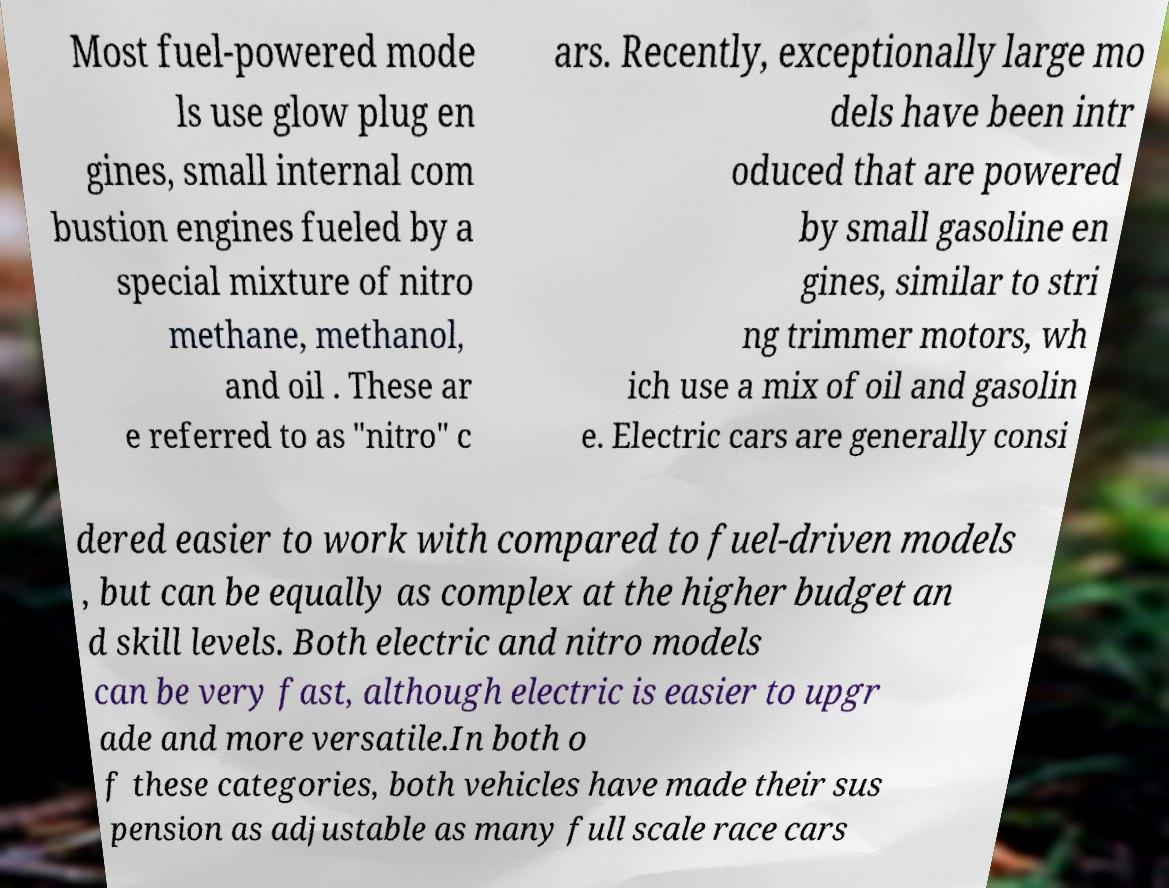For documentation purposes, I need the text within this image transcribed. Could you provide that? Most fuel-powered mode ls use glow plug en gines, small internal com bustion engines fueled by a special mixture of nitro methane, methanol, and oil . These ar e referred to as "nitro" c ars. Recently, exceptionally large mo dels have been intr oduced that are powered by small gasoline en gines, similar to stri ng trimmer motors, wh ich use a mix of oil and gasolin e. Electric cars are generally consi dered easier to work with compared to fuel-driven models , but can be equally as complex at the higher budget an d skill levels. Both electric and nitro models can be very fast, although electric is easier to upgr ade and more versatile.In both o f these categories, both vehicles have made their sus pension as adjustable as many full scale race cars 